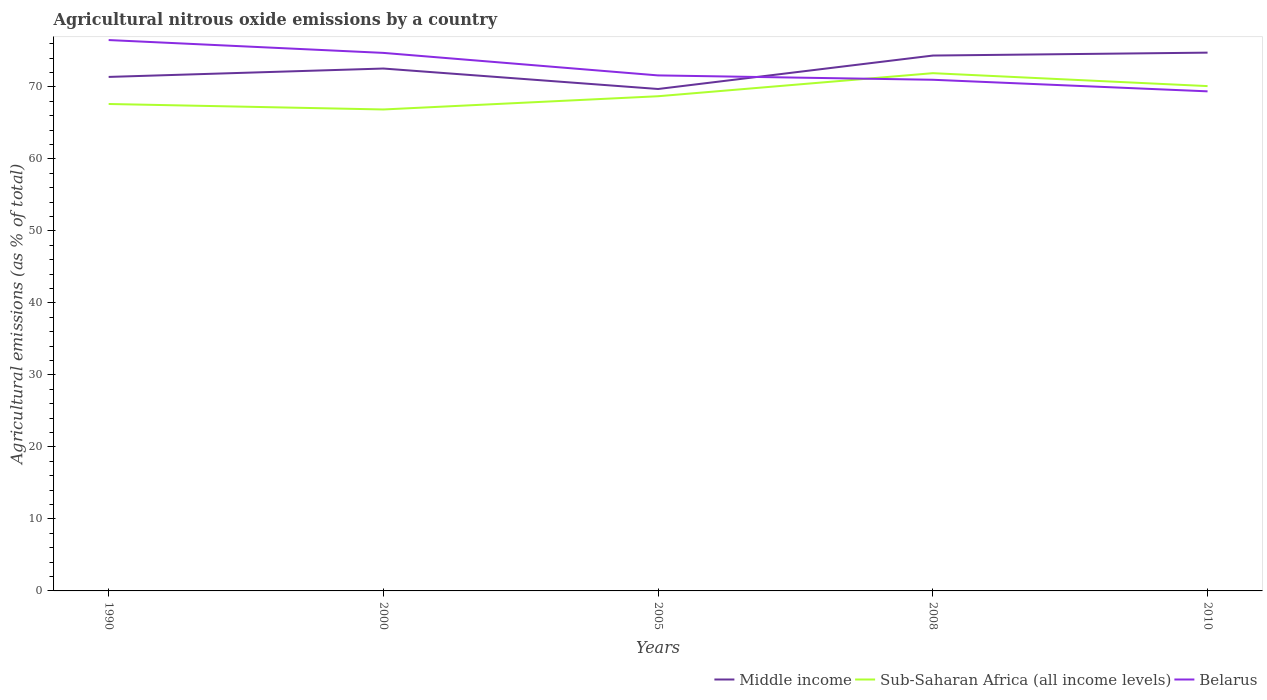How many different coloured lines are there?
Ensure brevity in your answer.  3. Does the line corresponding to Middle income intersect with the line corresponding to Belarus?
Ensure brevity in your answer.  Yes. Across all years, what is the maximum amount of agricultural nitrous oxide emitted in Belarus?
Provide a short and direct response. 69.37. What is the total amount of agricultural nitrous oxide emitted in Middle income in the graph?
Provide a succinct answer. -1.17. What is the difference between the highest and the second highest amount of agricultural nitrous oxide emitted in Belarus?
Offer a very short reply. 7.12. What is the difference between the highest and the lowest amount of agricultural nitrous oxide emitted in Belarus?
Give a very brief answer. 2. How many years are there in the graph?
Offer a terse response. 5. What is the difference between two consecutive major ticks on the Y-axis?
Make the answer very short. 10. Where does the legend appear in the graph?
Offer a very short reply. Bottom right. What is the title of the graph?
Ensure brevity in your answer.  Agricultural nitrous oxide emissions by a country. Does "Heavily indebted poor countries" appear as one of the legend labels in the graph?
Ensure brevity in your answer.  No. What is the label or title of the Y-axis?
Your response must be concise. Agricultural emissions (as % of total). What is the Agricultural emissions (as % of total) in Middle income in 1990?
Provide a short and direct response. 71.38. What is the Agricultural emissions (as % of total) in Sub-Saharan Africa (all income levels) in 1990?
Offer a terse response. 67.62. What is the Agricultural emissions (as % of total) in Belarus in 1990?
Your answer should be very brief. 76.5. What is the Agricultural emissions (as % of total) of Middle income in 2000?
Offer a very short reply. 72.54. What is the Agricultural emissions (as % of total) of Sub-Saharan Africa (all income levels) in 2000?
Offer a very short reply. 66.86. What is the Agricultural emissions (as % of total) of Belarus in 2000?
Your response must be concise. 74.72. What is the Agricultural emissions (as % of total) of Middle income in 2005?
Your response must be concise. 69.7. What is the Agricultural emissions (as % of total) of Sub-Saharan Africa (all income levels) in 2005?
Give a very brief answer. 68.7. What is the Agricultural emissions (as % of total) in Belarus in 2005?
Provide a succinct answer. 71.59. What is the Agricultural emissions (as % of total) in Middle income in 2008?
Offer a terse response. 74.35. What is the Agricultural emissions (as % of total) of Sub-Saharan Africa (all income levels) in 2008?
Make the answer very short. 71.9. What is the Agricultural emissions (as % of total) of Belarus in 2008?
Keep it short and to the point. 70.98. What is the Agricultural emissions (as % of total) of Middle income in 2010?
Make the answer very short. 74.75. What is the Agricultural emissions (as % of total) in Sub-Saharan Africa (all income levels) in 2010?
Provide a succinct answer. 70.1. What is the Agricultural emissions (as % of total) in Belarus in 2010?
Provide a short and direct response. 69.37. Across all years, what is the maximum Agricultural emissions (as % of total) in Middle income?
Offer a very short reply. 74.75. Across all years, what is the maximum Agricultural emissions (as % of total) of Sub-Saharan Africa (all income levels)?
Make the answer very short. 71.9. Across all years, what is the maximum Agricultural emissions (as % of total) of Belarus?
Offer a very short reply. 76.5. Across all years, what is the minimum Agricultural emissions (as % of total) in Middle income?
Your answer should be compact. 69.7. Across all years, what is the minimum Agricultural emissions (as % of total) of Sub-Saharan Africa (all income levels)?
Provide a short and direct response. 66.86. Across all years, what is the minimum Agricultural emissions (as % of total) of Belarus?
Provide a short and direct response. 69.37. What is the total Agricultural emissions (as % of total) in Middle income in the graph?
Your response must be concise. 362.72. What is the total Agricultural emissions (as % of total) in Sub-Saharan Africa (all income levels) in the graph?
Provide a succinct answer. 345.18. What is the total Agricultural emissions (as % of total) in Belarus in the graph?
Ensure brevity in your answer.  363.16. What is the difference between the Agricultural emissions (as % of total) in Middle income in 1990 and that in 2000?
Make the answer very short. -1.17. What is the difference between the Agricultural emissions (as % of total) in Sub-Saharan Africa (all income levels) in 1990 and that in 2000?
Your answer should be very brief. 0.76. What is the difference between the Agricultural emissions (as % of total) in Belarus in 1990 and that in 2000?
Give a very brief answer. 1.78. What is the difference between the Agricultural emissions (as % of total) in Middle income in 1990 and that in 2005?
Provide a short and direct response. 1.68. What is the difference between the Agricultural emissions (as % of total) of Sub-Saharan Africa (all income levels) in 1990 and that in 2005?
Keep it short and to the point. -1.08. What is the difference between the Agricultural emissions (as % of total) of Belarus in 1990 and that in 2005?
Give a very brief answer. 4.91. What is the difference between the Agricultural emissions (as % of total) in Middle income in 1990 and that in 2008?
Your answer should be very brief. -2.97. What is the difference between the Agricultural emissions (as % of total) in Sub-Saharan Africa (all income levels) in 1990 and that in 2008?
Your answer should be very brief. -4.28. What is the difference between the Agricultural emissions (as % of total) in Belarus in 1990 and that in 2008?
Provide a short and direct response. 5.51. What is the difference between the Agricultural emissions (as % of total) of Middle income in 1990 and that in 2010?
Keep it short and to the point. -3.37. What is the difference between the Agricultural emissions (as % of total) of Sub-Saharan Africa (all income levels) in 1990 and that in 2010?
Your answer should be compact. -2.48. What is the difference between the Agricultural emissions (as % of total) in Belarus in 1990 and that in 2010?
Offer a very short reply. 7.12. What is the difference between the Agricultural emissions (as % of total) in Middle income in 2000 and that in 2005?
Keep it short and to the point. 2.84. What is the difference between the Agricultural emissions (as % of total) of Sub-Saharan Africa (all income levels) in 2000 and that in 2005?
Keep it short and to the point. -1.84. What is the difference between the Agricultural emissions (as % of total) of Belarus in 2000 and that in 2005?
Offer a terse response. 3.13. What is the difference between the Agricultural emissions (as % of total) of Middle income in 2000 and that in 2008?
Your answer should be compact. -1.8. What is the difference between the Agricultural emissions (as % of total) of Sub-Saharan Africa (all income levels) in 2000 and that in 2008?
Give a very brief answer. -5.04. What is the difference between the Agricultural emissions (as % of total) in Belarus in 2000 and that in 2008?
Offer a very short reply. 3.73. What is the difference between the Agricultural emissions (as % of total) in Middle income in 2000 and that in 2010?
Your answer should be compact. -2.21. What is the difference between the Agricultural emissions (as % of total) of Sub-Saharan Africa (all income levels) in 2000 and that in 2010?
Your response must be concise. -3.24. What is the difference between the Agricultural emissions (as % of total) in Belarus in 2000 and that in 2010?
Offer a terse response. 5.34. What is the difference between the Agricultural emissions (as % of total) in Middle income in 2005 and that in 2008?
Ensure brevity in your answer.  -4.64. What is the difference between the Agricultural emissions (as % of total) of Sub-Saharan Africa (all income levels) in 2005 and that in 2008?
Provide a short and direct response. -3.2. What is the difference between the Agricultural emissions (as % of total) in Belarus in 2005 and that in 2008?
Offer a very short reply. 0.6. What is the difference between the Agricultural emissions (as % of total) in Middle income in 2005 and that in 2010?
Make the answer very short. -5.05. What is the difference between the Agricultural emissions (as % of total) of Sub-Saharan Africa (all income levels) in 2005 and that in 2010?
Give a very brief answer. -1.41. What is the difference between the Agricultural emissions (as % of total) of Belarus in 2005 and that in 2010?
Your response must be concise. 2.21. What is the difference between the Agricultural emissions (as % of total) in Middle income in 2008 and that in 2010?
Provide a short and direct response. -0.4. What is the difference between the Agricultural emissions (as % of total) in Sub-Saharan Africa (all income levels) in 2008 and that in 2010?
Provide a succinct answer. 1.79. What is the difference between the Agricultural emissions (as % of total) of Belarus in 2008 and that in 2010?
Your answer should be compact. 1.61. What is the difference between the Agricultural emissions (as % of total) of Middle income in 1990 and the Agricultural emissions (as % of total) of Sub-Saharan Africa (all income levels) in 2000?
Keep it short and to the point. 4.52. What is the difference between the Agricultural emissions (as % of total) in Middle income in 1990 and the Agricultural emissions (as % of total) in Belarus in 2000?
Your answer should be compact. -3.34. What is the difference between the Agricultural emissions (as % of total) in Sub-Saharan Africa (all income levels) in 1990 and the Agricultural emissions (as % of total) in Belarus in 2000?
Offer a terse response. -7.09. What is the difference between the Agricultural emissions (as % of total) of Middle income in 1990 and the Agricultural emissions (as % of total) of Sub-Saharan Africa (all income levels) in 2005?
Offer a terse response. 2.68. What is the difference between the Agricultural emissions (as % of total) of Middle income in 1990 and the Agricultural emissions (as % of total) of Belarus in 2005?
Provide a succinct answer. -0.21. What is the difference between the Agricultural emissions (as % of total) in Sub-Saharan Africa (all income levels) in 1990 and the Agricultural emissions (as % of total) in Belarus in 2005?
Your answer should be compact. -3.97. What is the difference between the Agricultural emissions (as % of total) of Middle income in 1990 and the Agricultural emissions (as % of total) of Sub-Saharan Africa (all income levels) in 2008?
Your answer should be compact. -0.52. What is the difference between the Agricultural emissions (as % of total) of Middle income in 1990 and the Agricultural emissions (as % of total) of Belarus in 2008?
Your answer should be compact. 0.39. What is the difference between the Agricultural emissions (as % of total) in Sub-Saharan Africa (all income levels) in 1990 and the Agricultural emissions (as % of total) in Belarus in 2008?
Your answer should be compact. -3.36. What is the difference between the Agricultural emissions (as % of total) of Middle income in 1990 and the Agricultural emissions (as % of total) of Sub-Saharan Africa (all income levels) in 2010?
Your answer should be compact. 1.27. What is the difference between the Agricultural emissions (as % of total) in Middle income in 1990 and the Agricultural emissions (as % of total) in Belarus in 2010?
Make the answer very short. 2. What is the difference between the Agricultural emissions (as % of total) in Sub-Saharan Africa (all income levels) in 1990 and the Agricultural emissions (as % of total) in Belarus in 2010?
Your answer should be compact. -1.75. What is the difference between the Agricultural emissions (as % of total) of Middle income in 2000 and the Agricultural emissions (as % of total) of Sub-Saharan Africa (all income levels) in 2005?
Make the answer very short. 3.85. What is the difference between the Agricultural emissions (as % of total) in Middle income in 2000 and the Agricultural emissions (as % of total) in Belarus in 2005?
Offer a very short reply. 0.96. What is the difference between the Agricultural emissions (as % of total) in Sub-Saharan Africa (all income levels) in 2000 and the Agricultural emissions (as % of total) in Belarus in 2005?
Your answer should be compact. -4.73. What is the difference between the Agricultural emissions (as % of total) of Middle income in 2000 and the Agricultural emissions (as % of total) of Sub-Saharan Africa (all income levels) in 2008?
Keep it short and to the point. 0.65. What is the difference between the Agricultural emissions (as % of total) of Middle income in 2000 and the Agricultural emissions (as % of total) of Belarus in 2008?
Make the answer very short. 1.56. What is the difference between the Agricultural emissions (as % of total) of Sub-Saharan Africa (all income levels) in 2000 and the Agricultural emissions (as % of total) of Belarus in 2008?
Your answer should be compact. -4.13. What is the difference between the Agricultural emissions (as % of total) of Middle income in 2000 and the Agricultural emissions (as % of total) of Sub-Saharan Africa (all income levels) in 2010?
Provide a short and direct response. 2.44. What is the difference between the Agricultural emissions (as % of total) of Middle income in 2000 and the Agricultural emissions (as % of total) of Belarus in 2010?
Make the answer very short. 3.17. What is the difference between the Agricultural emissions (as % of total) in Sub-Saharan Africa (all income levels) in 2000 and the Agricultural emissions (as % of total) in Belarus in 2010?
Offer a terse response. -2.52. What is the difference between the Agricultural emissions (as % of total) of Middle income in 2005 and the Agricultural emissions (as % of total) of Sub-Saharan Africa (all income levels) in 2008?
Your answer should be very brief. -2.2. What is the difference between the Agricultural emissions (as % of total) of Middle income in 2005 and the Agricultural emissions (as % of total) of Belarus in 2008?
Give a very brief answer. -1.28. What is the difference between the Agricultural emissions (as % of total) in Sub-Saharan Africa (all income levels) in 2005 and the Agricultural emissions (as % of total) in Belarus in 2008?
Your answer should be very brief. -2.29. What is the difference between the Agricultural emissions (as % of total) in Middle income in 2005 and the Agricultural emissions (as % of total) in Sub-Saharan Africa (all income levels) in 2010?
Provide a short and direct response. -0.4. What is the difference between the Agricultural emissions (as % of total) in Middle income in 2005 and the Agricultural emissions (as % of total) in Belarus in 2010?
Offer a very short reply. 0.33. What is the difference between the Agricultural emissions (as % of total) in Sub-Saharan Africa (all income levels) in 2005 and the Agricultural emissions (as % of total) in Belarus in 2010?
Your answer should be very brief. -0.68. What is the difference between the Agricultural emissions (as % of total) of Middle income in 2008 and the Agricultural emissions (as % of total) of Sub-Saharan Africa (all income levels) in 2010?
Give a very brief answer. 4.24. What is the difference between the Agricultural emissions (as % of total) in Middle income in 2008 and the Agricultural emissions (as % of total) in Belarus in 2010?
Offer a terse response. 4.97. What is the difference between the Agricultural emissions (as % of total) in Sub-Saharan Africa (all income levels) in 2008 and the Agricultural emissions (as % of total) in Belarus in 2010?
Ensure brevity in your answer.  2.52. What is the average Agricultural emissions (as % of total) of Middle income per year?
Provide a succinct answer. 72.54. What is the average Agricultural emissions (as % of total) of Sub-Saharan Africa (all income levels) per year?
Your answer should be compact. 69.04. What is the average Agricultural emissions (as % of total) in Belarus per year?
Provide a short and direct response. 72.63. In the year 1990, what is the difference between the Agricultural emissions (as % of total) of Middle income and Agricultural emissions (as % of total) of Sub-Saharan Africa (all income levels)?
Ensure brevity in your answer.  3.76. In the year 1990, what is the difference between the Agricultural emissions (as % of total) in Middle income and Agricultural emissions (as % of total) in Belarus?
Ensure brevity in your answer.  -5.12. In the year 1990, what is the difference between the Agricultural emissions (as % of total) of Sub-Saharan Africa (all income levels) and Agricultural emissions (as % of total) of Belarus?
Make the answer very short. -8.88. In the year 2000, what is the difference between the Agricultural emissions (as % of total) in Middle income and Agricultural emissions (as % of total) in Sub-Saharan Africa (all income levels)?
Your answer should be very brief. 5.69. In the year 2000, what is the difference between the Agricultural emissions (as % of total) in Middle income and Agricultural emissions (as % of total) in Belarus?
Keep it short and to the point. -2.17. In the year 2000, what is the difference between the Agricultural emissions (as % of total) in Sub-Saharan Africa (all income levels) and Agricultural emissions (as % of total) in Belarus?
Offer a terse response. -7.86. In the year 2005, what is the difference between the Agricultural emissions (as % of total) in Middle income and Agricultural emissions (as % of total) in Sub-Saharan Africa (all income levels)?
Offer a very short reply. 1. In the year 2005, what is the difference between the Agricultural emissions (as % of total) of Middle income and Agricultural emissions (as % of total) of Belarus?
Your response must be concise. -1.89. In the year 2005, what is the difference between the Agricultural emissions (as % of total) of Sub-Saharan Africa (all income levels) and Agricultural emissions (as % of total) of Belarus?
Your response must be concise. -2.89. In the year 2008, what is the difference between the Agricultural emissions (as % of total) of Middle income and Agricultural emissions (as % of total) of Sub-Saharan Africa (all income levels)?
Your response must be concise. 2.45. In the year 2008, what is the difference between the Agricultural emissions (as % of total) in Middle income and Agricultural emissions (as % of total) in Belarus?
Keep it short and to the point. 3.36. In the year 2008, what is the difference between the Agricultural emissions (as % of total) of Sub-Saharan Africa (all income levels) and Agricultural emissions (as % of total) of Belarus?
Offer a terse response. 0.91. In the year 2010, what is the difference between the Agricultural emissions (as % of total) of Middle income and Agricultural emissions (as % of total) of Sub-Saharan Africa (all income levels)?
Your response must be concise. 4.65. In the year 2010, what is the difference between the Agricultural emissions (as % of total) of Middle income and Agricultural emissions (as % of total) of Belarus?
Your answer should be compact. 5.37. In the year 2010, what is the difference between the Agricultural emissions (as % of total) in Sub-Saharan Africa (all income levels) and Agricultural emissions (as % of total) in Belarus?
Keep it short and to the point. 0.73. What is the ratio of the Agricultural emissions (as % of total) of Middle income in 1990 to that in 2000?
Your answer should be compact. 0.98. What is the ratio of the Agricultural emissions (as % of total) in Sub-Saharan Africa (all income levels) in 1990 to that in 2000?
Your answer should be very brief. 1.01. What is the ratio of the Agricultural emissions (as % of total) of Belarus in 1990 to that in 2000?
Make the answer very short. 1.02. What is the ratio of the Agricultural emissions (as % of total) of Middle income in 1990 to that in 2005?
Your response must be concise. 1.02. What is the ratio of the Agricultural emissions (as % of total) in Sub-Saharan Africa (all income levels) in 1990 to that in 2005?
Provide a succinct answer. 0.98. What is the ratio of the Agricultural emissions (as % of total) of Belarus in 1990 to that in 2005?
Provide a short and direct response. 1.07. What is the ratio of the Agricultural emissions (as % of total) in Middle income in 1990 to that in 2008?
Make the answer very short. 0.96. What is the ratio of the Agricultural emissions (as % of total) in Sub-Saharan Africa (all income levels) in 1990 to that in 2008?
Provide a succinct answer. 0.94. What is the ratio of the Agricultural emissions (as % of total) in Belarus in 1990 to that in 2008?
Provide a short and direct response. 1.08. What is the ratio of the Agricultural emissions (as % of total) in Middle income in 1990 to that in 2010?
Make the answer very short. 0.95. What is the ratio of the Agricultural emissions (as % of total) of Sub-Saharan Africa (all income levels) in 1990 to that in 2010?
Keep it short and to the point. 0.96. What is the ratio of the Agricultural emissions (as % of total) of Belarus in 1990 to that in 2010?
Your answer should be compact. 1.1. What is the ratio of the Agricultural emissions (as % of total) in Middle income in 2000 to that in 2005?
Offer a very short reply. 1.04. What is the ratio of the Agricultural emissions (as % of total) of Sub-Saharan Africa (all income levels) in 2000 to that in 2005?
Provide a succinct answer. 0.97. What is the ratio of the Agricultural emissions (as % of total) of Belarus in 2000 to that in 2005?
Ensure brevity in your answer.  1.04. What is the ratio of the Agricultural emissions (as % of total) in Middle income in 2000 to that in 2008?
Make the answer very short. 0.98. What is the ratio of the Agricultural emissions (as % of total) in Sub-Saharan Africa (all income levels) in 2000 to that in 2008?
Provide a succinct answer. 0.93. What is the ratio of the Agricultural emissions (as % of total) of Belarus in 2000 to that in 2008?
Offer a very short reply. 1.05. What is the ratio of the Agricultural emissions (as % of total) of Middle income in 2000 to that in 2010?
Offer a terse response. 0.97. What is the ratio of the Agricultural emissions (as % of total) of Sub-Saharan Africa (all income levels) in 2000 to that in 2010?
Your answer should be very brief. 0.95. What is the ratio of the Agricultural emissions (as % of total) of Belarus in 2000 to that in 2010?
Offer a terse response. 1.08. What is the ratio of the Agricultural emissions (as % of total) of Sub-Saharan Africa (all income levels) in 2005 to that in 2008?
Offer a very short reply. 0.96. What is the ratio of the Agricultural emissions (as % of total) of Belarus in 2005 to that in 2008?
Provide a short and direct response. 1.01. What is the ratio of the Agricultural emissions (as % of total) in Middle income in 2005 to that in 2010?
Offer a terse response. 0.93. What is the ratio of the Agricultural emissions (as % of total) of Sub-Saharan Africa (all income levels) in 2005 to that in 2010?
Offer a terse response. 0.98. What is the ratio of the Agricultural emissions (as % of total) of Belarus in 2005 to that in 2010?
Give a very brief answer. 1.03. What is the ratio of the Agricultural emissions (as % of total) of Middle income in 2008 to that in 2010?
Your response must be concise. 0.99. What is the ratio of the Agricultural emissions (as % of total) in Sub-Saharan Africa (all income levels) in 2008 to that in 2010?
Your response must be concise. 1.03. What is the ratio of the Agricultural emissions (as % of total) in Belarus in 2008 to that in 2010?
Make the answer very short. 1.02. What is the difference between the highest and the second highest Agricultural emissions (as % of total) in Middle income?
Provide a short and direct response. 0.4. What is the difference between the highest and the second highest Agricultural emissions (as % of total) of Sub-Saharan Africa (all income levels)?
Provide a short and direct response. 1.79. What is the difference between the highest and the second highest Agricultural emissions (as % of total) in Belarus?
Keep it short and to the point. 1.78. What is the difference between the highest and the lowest Agricultural emissions (as % of total) in Middle income?
Provide a succinct answer. 5.05. What is the difference between the highest and the lowest Agricultural emissions (as % of total) in Sub-Saharan Africa (all income levels)?
Make the answer very short. 5.04. What is the difference between the highest and the lowest Agricultural emissions (as % of total) of Belarus?
Offer a very short reply. 7.12. 